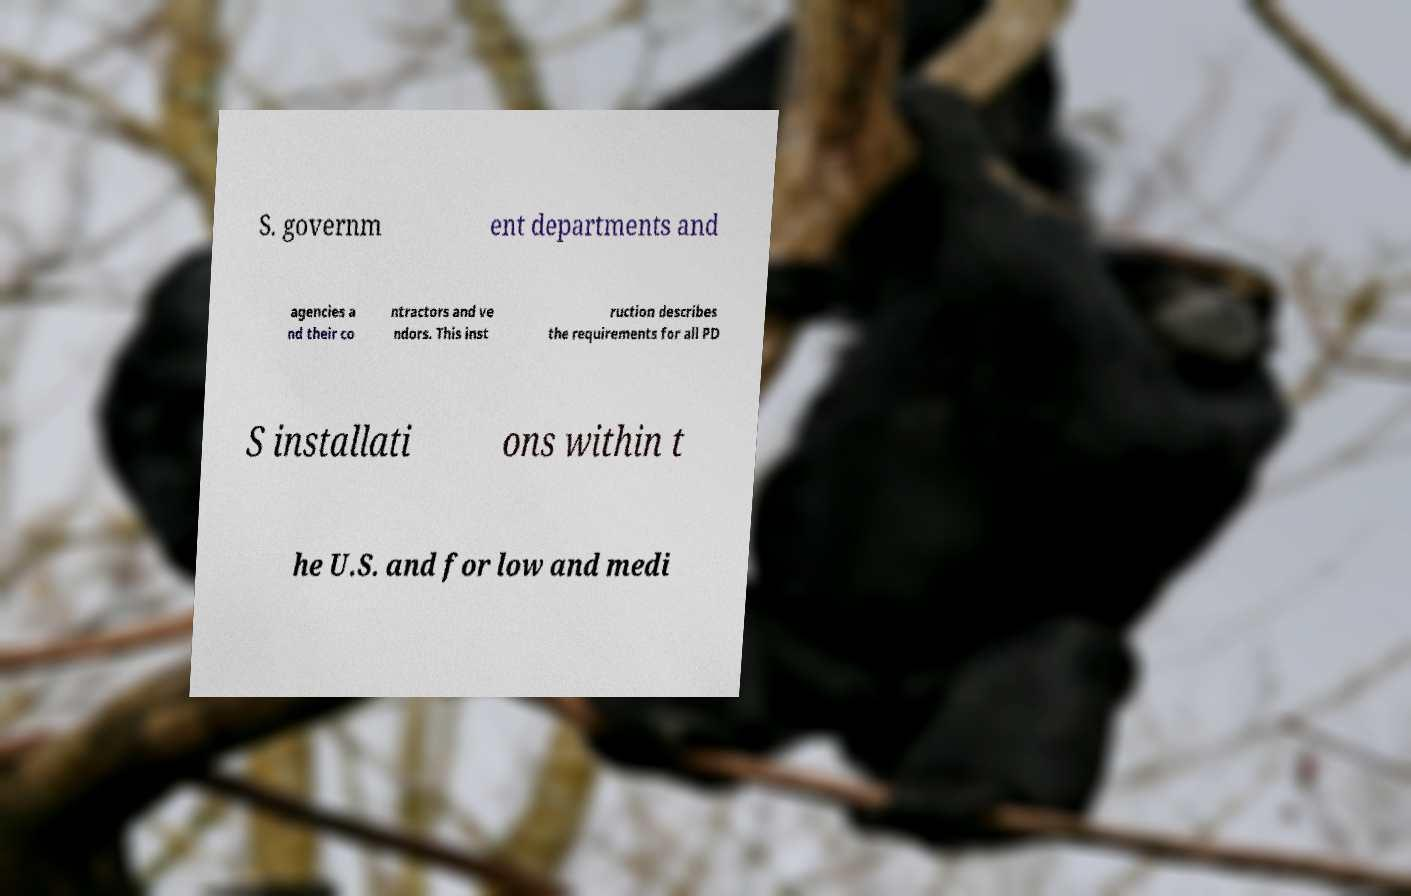There's text embedded in this image that I need extracted. Can you transcribe it verbatim? S. governm ent departments and agencies a nd their co ntractors and ve ndors. This inst ruction describes the requirements for all PD S installati ons within t he U.S. and for low and medi 